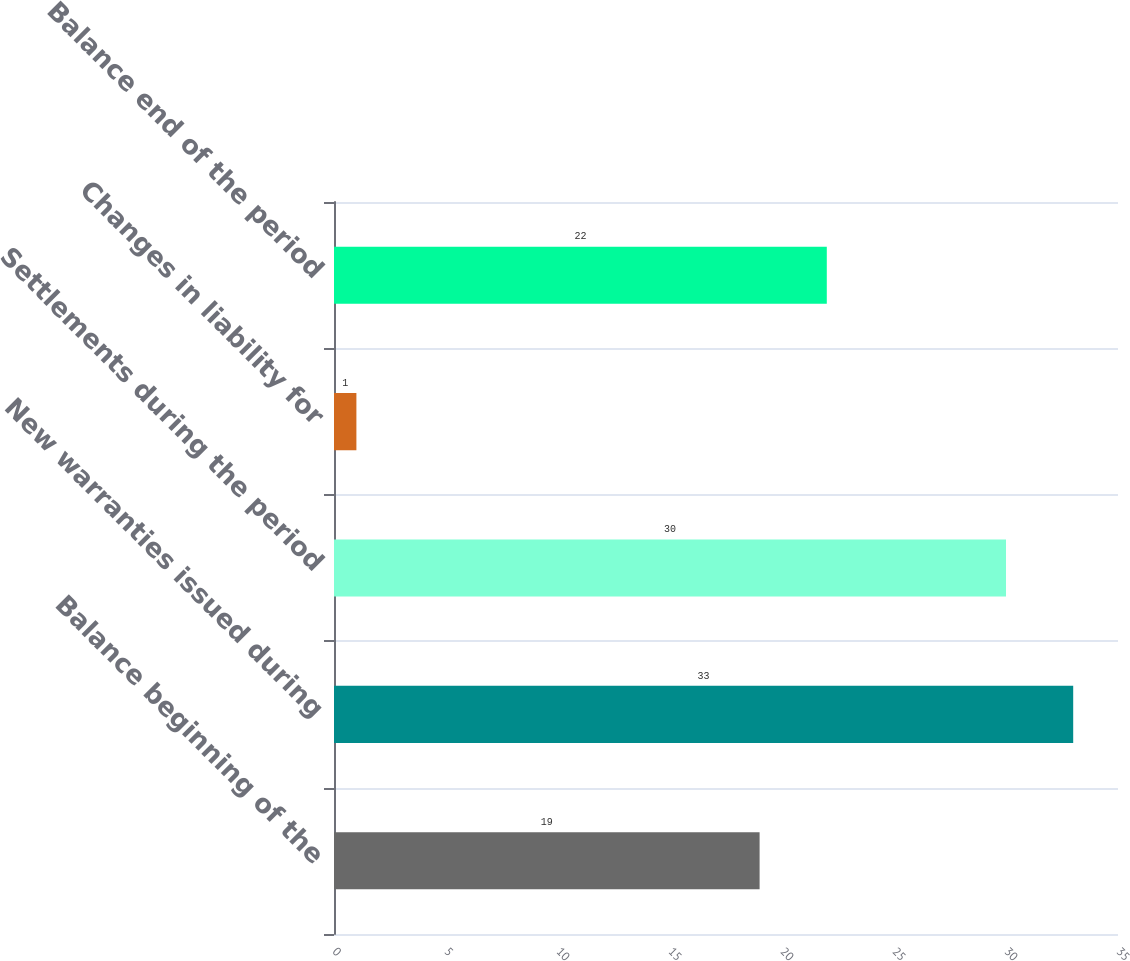Convert chart. <chart><loc_0><loc_0><loc_500><loc_500><bar_chart><fcel>Balance beginning of the<fcel>New warranties issued during<fcel>Settlements during the period<fcel>Changes in liability for<fcel>Balance end of the period<nl><fcel>19<fcel>33<fcel>30<fcel>1<fcel>22<nl></chart> 